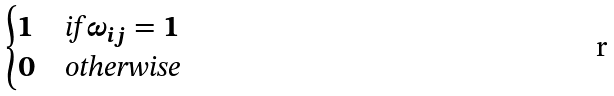Convert formula to latex. <formula><loc_0><loc_0><loc_500><loc_500>\begin{cases} 1 & \text {if} \, \omega _ { i j } = 1 \\ 0 & \text {otherwise} \end{cases}</formula> 